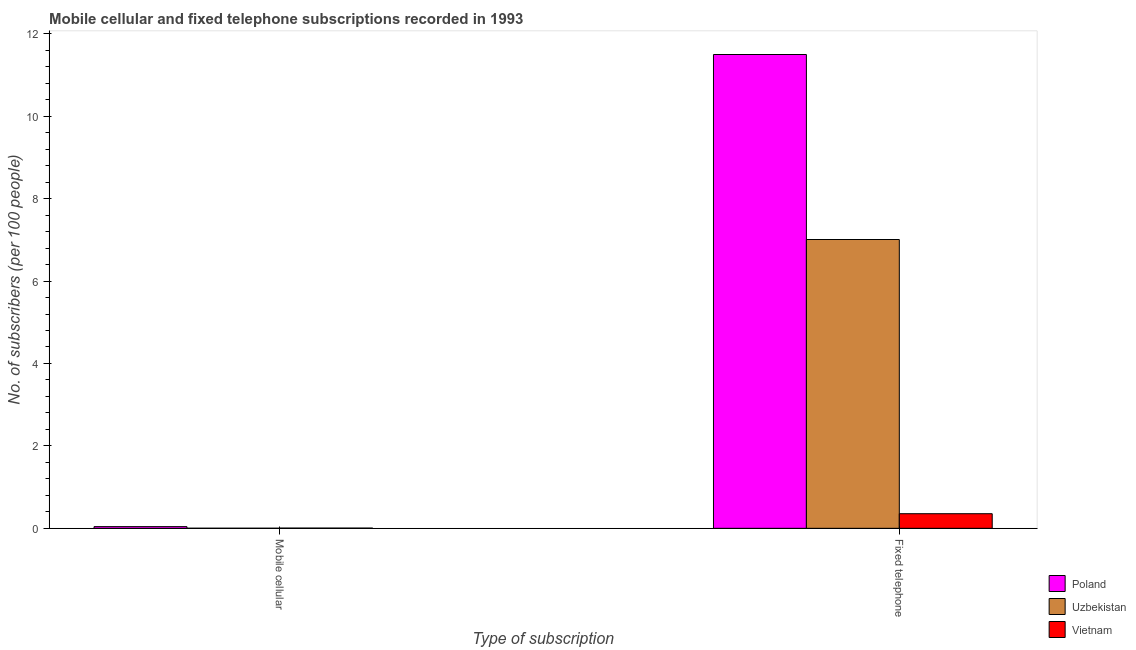Are the number of bars per tick equal to the number of legend labels?
Your answer should be compact. Yes. How many bars are there on the 2nd tick from the left?
Make the answer very short. 3. What is the label of the 1st group of bars from the left?
Your answer should be compact. Mobile cellular. What is the number of mobile cellular subscribers in Uzbekistan?
Your answer should be very brief. 0. Across all countries, what is the maximum number of mobile cellular subscribers?
Keep it short and to the point. 0.04. Across all countries, what is the minimum number of mobile cellular subscribers?
Offer a very short reply. 0. In which country was the number of mobile cellular subscribers maximum?
Keep it short and to the point. Poland. In which country was the number of fixed telephone subscribers minimum?
Make the answer very short. Vietnam. What is the total number of mobile cellular subscribers in the graph?
Your answer should be very brief. 0.05. What is the difference between the number of mobile cellular subscribers in Vietnam and that in Poland?
Keep it short and to the point. -0.04. What is the difference between the number of mobile cellular subscribers in Poland and the number of fixed telephone subscribers in Vietnam?
Give a very brief answer. -0.31. What is the average number of fixed telephone subscribers per country?
Your response must be concise. 6.29. What is the difference between the number of mobile cellular subscribers and number of fixed telephone subscribers in Poland?
Provide a succinct answer. -11.46. In how many countries, is the number of fixed telephone subscribers greater than 4.4 ?
Provide a succinct answer. 2. What is the ratio of the number of fixed telephone subscribers in Vietnam to that in Uzbekistan?
Give a very brief answer. 0.05. What does the 2nd bar from the left in Mobile cellular represents?
Give a very brief answer. Uzbekistan. What does the 2nd bar from the right in Fixed telephone represents?
Keep it short and to the point. Uzbekistan. How many bars are there?
Make the answer very short. 6. Are the values on the major ticks of Y-axis written in scientific E-notation?
Keep it short and to the point. No. Does the graph contain any zero values?
Give a very brief answer. No. Where does the legend appear in the graph?
Your answer should be compact. Bottom right. What is the title of the graph?
Your answer should be very brief. Mobile cellular and fixed telephone subscriptions recorded in 1993. Does "Djibouti" appear as one of the legend labels in the graph?
Your response must be concise. No. What is the label or title of the X-axis?
Your answer should be compact. Type of subscription. What is the label or title of the Y-axis?
Give a very brief answer. No. of subscribers (per 100 people). What is the No. of subscribers (per 100 people) in Poland in Mobile cellular?
Offer a very short reply. 0.04. What is the No. of subscribers (per 100 people) in Uzbekistan in Mobile cellular?
Keep it short and to the point. 0. What is the No. of subscribers (per 100 people) in Vietnam in Mobile cellular?
Your answer should be very brief. 0.01. What is the No. of subscribers (per 100 people) of Poland in Fixed telephone?
Offer a very short reply. 11.5. What is the No. of subscribers (per 100 people) in Uzbekistan in Fixed telephone?
Ensure brevity in your answer.  7.01. What is the No. of subscribers (per 100 people) in Vietnam in Fixed telephone?
Give a very brief answer. 0.35. Across all Type of subscription, what is the maximum No. of subscribers (per 100 people) in Poland?
Your answer should be compact. 11.5. Across all Type of subscription, what is the maximum No. of subscribers (per 100 people) of Uzbekistan?
Your answer should be very brief. 7.01. Across all Type of subscription, what is the maximum No. of subscribers (per 100 people) of Vietnam?
Keep it short and to the point. 0.35. Across all Type of subscription, what is the minimum No. of subscribers (per 100 people) of Poland?
Your answer should be compact. 0.04. Across all Type of subscription, what is the minimum No. of subscribers (per 100 people) in Uzbekistan?
Your answer should be compact. 0. Across all Type of subscription, what is the minimum No. of subscribers (per 100 people) of Vietnam?
Your answer should be compact. 0.01. What is the total No. of subscribers (per 100 people) of Poland in the graph?
Keep it short and to the point. 11.54. What is the total No. of subscribers (per 100 people) of Uzbekistan in the graph?
Ensure brevity in your answer.  7.01. What is the total No. of subscribers (per 100 people) in Vietnam in the graph?
Your answer should be compact. 0.36. What is the difference between the No. of subscribers (per 100 people) in Poland in Mobile cellular and that in Fixed telephone?
Make the answer very short. -11.46. What is the difference between the No. of subscribers (per 100 people) of Uzbekistan in Mobile cellular and that in Fixed telephone?
Keep it short and to the point. -7.01. What is the difference between the No. of subscribers (per 100 people) in Vietnam in Mobile cellular and that in Fixed telephone?
Your response must be concise. -0.35. What is the difference between the No. of subscribers (per 100 people) of Poland in Mobile cellular and the No. of subscribers (per 100 people) of Uzbekistan in Fixed telephone?
Offer a terse response. -6.97. What is the difference between the No. of subscribers (per 100 people) in Poland in Mobile cellular and the No. of subscribers (per 100 people) in Vietnam in Fixed telephone?
Offer a terse response. -0.31. What is the difference between the No. of subscribers (per 100 people) of Uzbekistan in Mobile cellular and the No. of subscribers (per 100 people) of Vietnam in Fixed telephone?
Provide a succinct answer. -0.35. What is the average No. of subscribers (per 100 people) of Poland per Type of subscription?
Offer a very short reply. 5.77. What is the average No. of subscribers (per 100 people) in Uzbekistan per Type of subscription?
Offer a terse response. 3.5. What is the average No. of subscribers (per 100 people) of Vietnam per Type of subscription?
Keep it short and to the point. 0.18. What is the difference between the No. of subscribers (per 100 people) in Poland and No. of subscribers (per 100 people) in Uzbekistan in Mobile cellular?
Offer a terse response. 0.04. What is the difference between the No. of subscribers (per 100 people) of Poland and No. of subscribers (per 100 people) of Vietnam in Mobile cellular?
Make the answer very short. 0.04. What is the difference between the No. of subscribers (per 100 people) in Uzbekistan and No. of subscribers (per 100 people) in Vietnam in Mobile cellular?
Keep it short and to the point. -0. What is the difference between the No. of subscribers (per 100 people) of Poland and No. of subscribers (per 100 people) of Uzbekistan in Fixed telephone?
Your answer should be compact. 4.49. What is the difference between the No. of subscribers (per 100 people) in Poland and No. of subscribers (per 100 people) in Vietnam in Fixed telephone?
Provide a succinct answer. 11.14. What is the difference between the No. of subscribers (per 100 people) in Uzbekistan and No. of subscribers (per 100 people) in Vietnam in Fixed telephone?
Ensure brevity in your answer.  6.65. What is the ratio of the No. of subscribers (per 100 people) of Poland in Mobile cellular to that in Fixed telephone?
Provide a short and direct response. 0. What is the ratio of the No. of subscribers (per 100 people) of Uzbekistan in Mobile cellular to that in Fixed telephone?
Offer a terse response. 0. What is the ratio of the No. of subscribers (per 100 people) in Vietnam in Mobile cellular to that in Fixed telephone?
Give a very brief answer. 0.02. What is the difference between the highest and the second highest No. of subscribers (per 100 people) of Poland?
Ensure brevity in your answer.  11.46. What is the difference between the highest and the second highest No. of subscribers (per 100 people) of Uzbekistan?
Offer a very short reply. 7.01. What is the difference between the highest and the second highest No. of subscribers (per 100 people) of Vietnam?
Your response must be concise. 0.35. What is the difference between the highest and the lowest No. of subscribers (per 100 people) in Poland?
Ensure brevity in your answer.  11.46. What is the difference between the highest and the lowest No. of subscribers (per 100 people) in Uzbekistan?
Your response must be concise. 7.01. What is the difference between the highest and the lowest No. of subscribers (per 100 people) of Vietnam?
Your answer should be very brief. 0.35. 